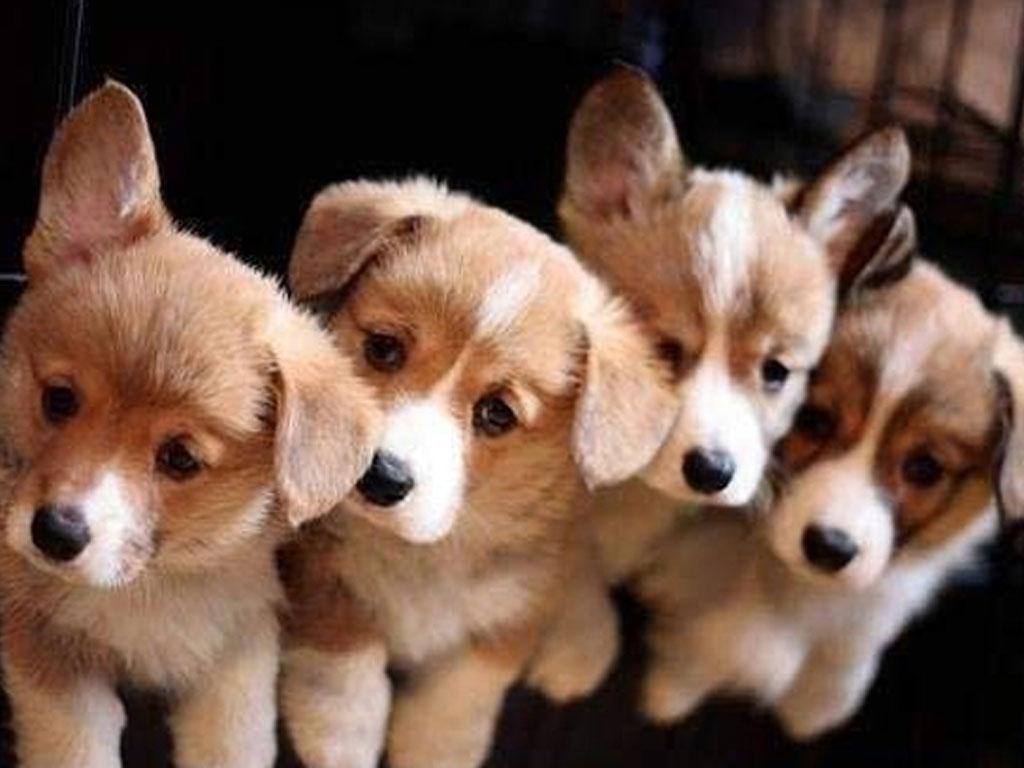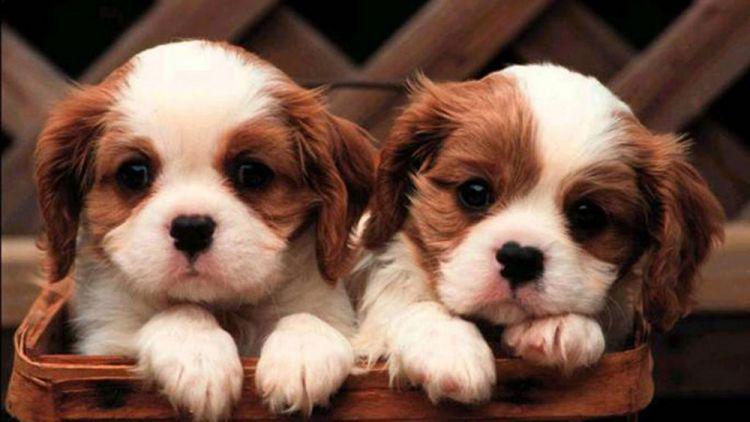The first image is the image on the left, the second image is the image on the right. Evaluate the accuracy of this statement regarding the images: "An image shows at least three similarly sized dogs posed in a row.". Is it true? Answer yes or no. Yes. 